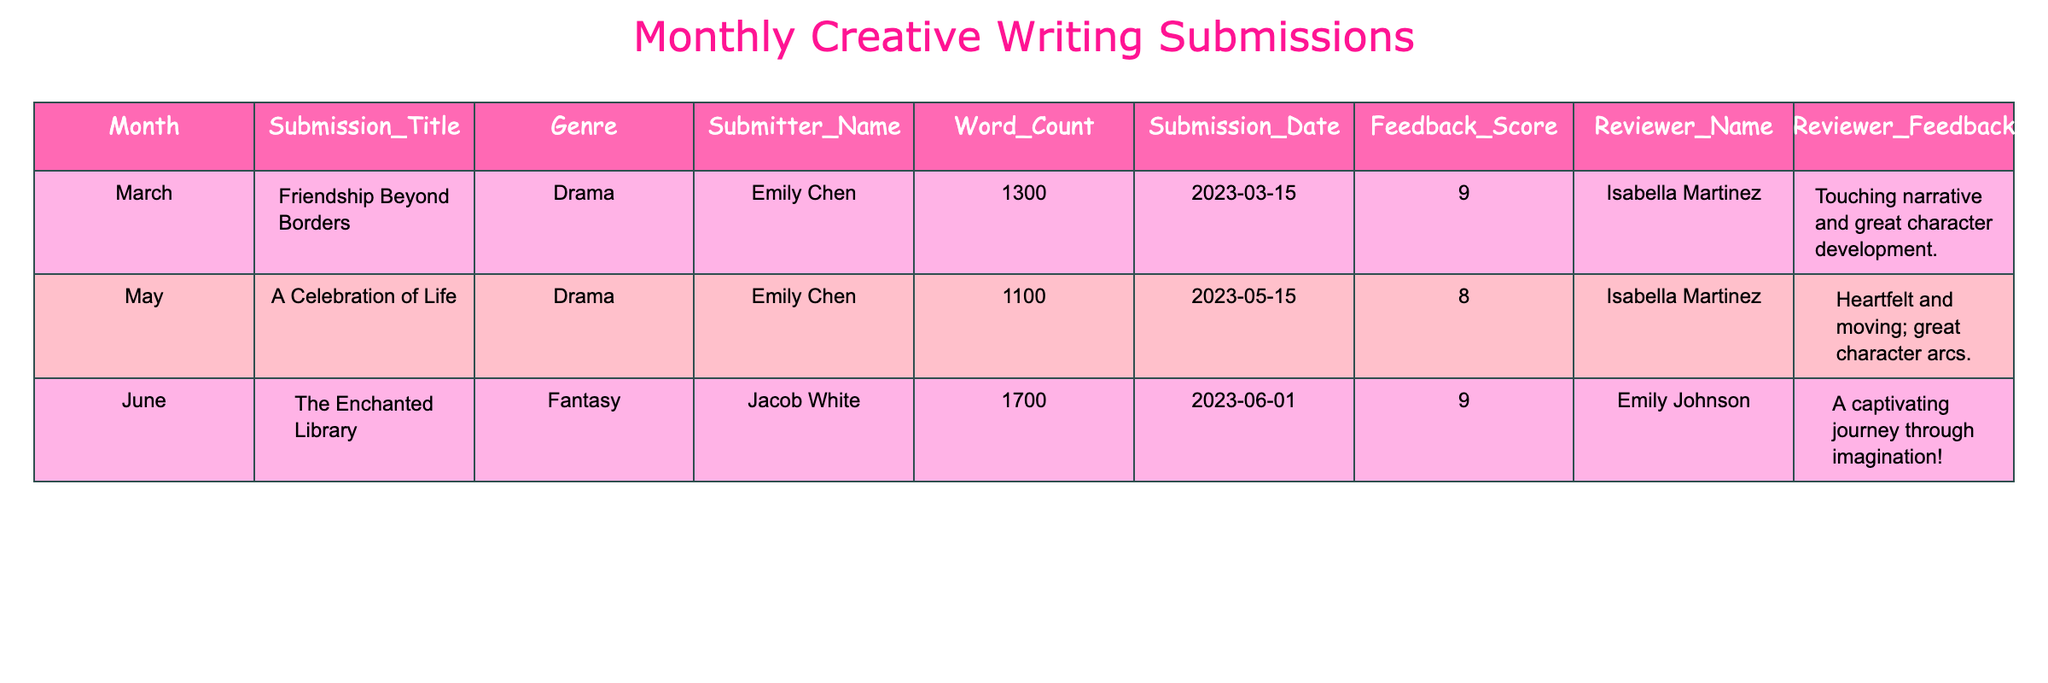What genre has the highest number of submissions? The table shows three submissions: two are Drama and one is Fantasy. Therefore, Drama has the highest count of submissions.
Answer: Drama Who submitted "Friendship Beyond Borders"? The Submission_Title "Friendship Beyond Borders" corresponds to the submitter Emily Chen, as recorded in the table.
Answer: Emily Chen What was the feedback score for "The Enchanted Library"? The table states that the Feedback_Score for "The Enchanted Library" is 9.
Answer: 9 Which submission had the highest word count? The word counts in the table are 1300 for "Friendship Beyond Borders", 1100 for "A Celebration of Life", and 1700 for "The Enchanted Library". Comparing these, "The Enchanted Library" has the highest word count.
Answer: The Enchanted Library Is there any submission with a feedback score of 10? There are three submissions listed in the table, and all have feedback scores of 8 or 9. Thus, there is no submission with a feedback score of 10.
Answer: No What is the average feedback score for all submissions? The feedback scores are 9, 8, and 9. To find the average, we add these scores: (9 + 8 + 9) = 26, and then divide by the number of submissions (3): 26 / 3 = 8.67.
Answer: 8.67 If we consider only the Drama submissions, what is the average word count? The Drama submissions are "Friendship Beyond Borders" (1300 words) and "A Celebration of Life" (1100 words). Adding their word counts gives us 1300 + 1100 = 2400. There are 2 submissions, so the average is 2400 / 2 = 1200.
Answer: 1200 Which reviewer provided feedback on the most submissions? The table shows that Isabella Martinez reviewed two submissions ("Friendship Beyond Borders" and "A Celebration of Life"), while Emily Johnson reviewed one. Therefore, Isabella Martinez provided feedback on the most submissions.
Answer: Isabella Martinez Was there a submission in March? The table lists a submission titled "Friendship Beyond Borders" with a submission date on March 15, 2023. Therefore, there was indeed a submission in March.
Answer: Yes What is the total word count of all submissions combined? The word counts from the table are 1300, 1100, and 1700. Adding these together gives 1300 + 1100 + 1700 = 4100.
Answer: 4100 